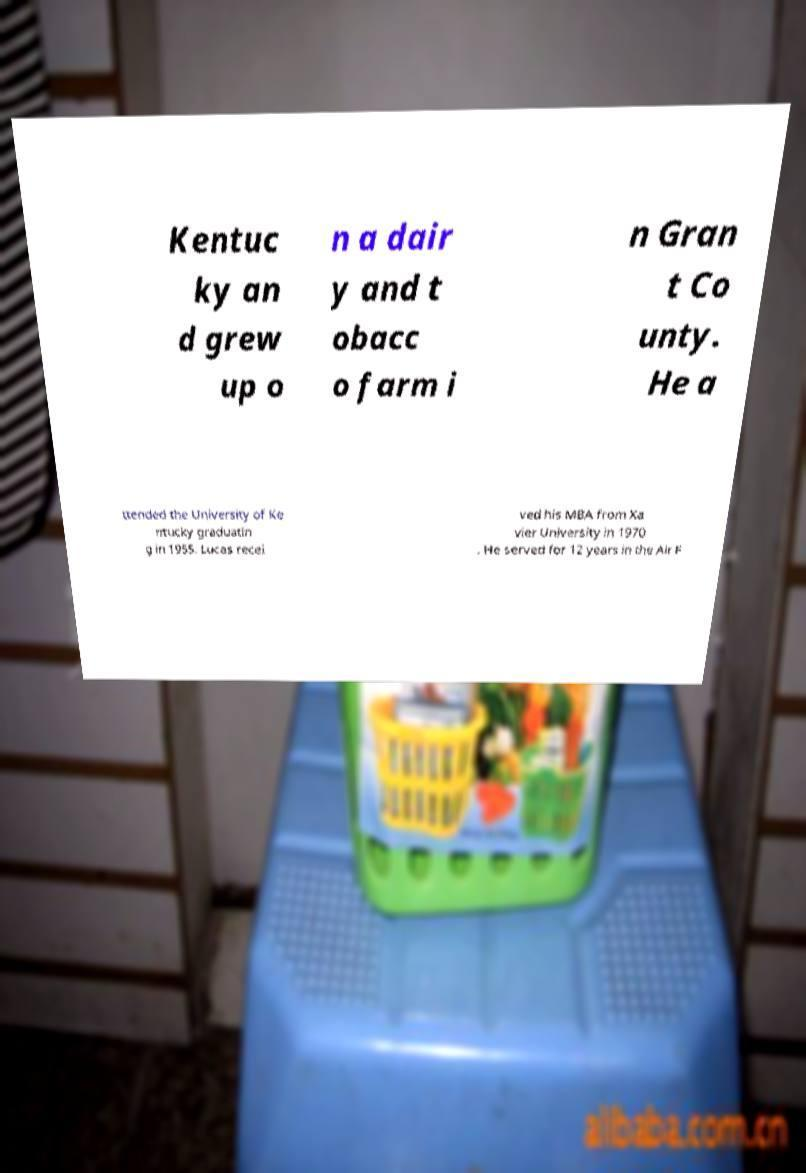Could you extract and type out the text from this image? Kentuc ky an d grew up o n a dair y and t obacc o farm i n Gran t Co unty. He a ttended the University of Ke ntucky graduatin g in 1955. Lucas recei ved his MBA from Xa vier University in 1970 . He served for 12 years in the Air F 